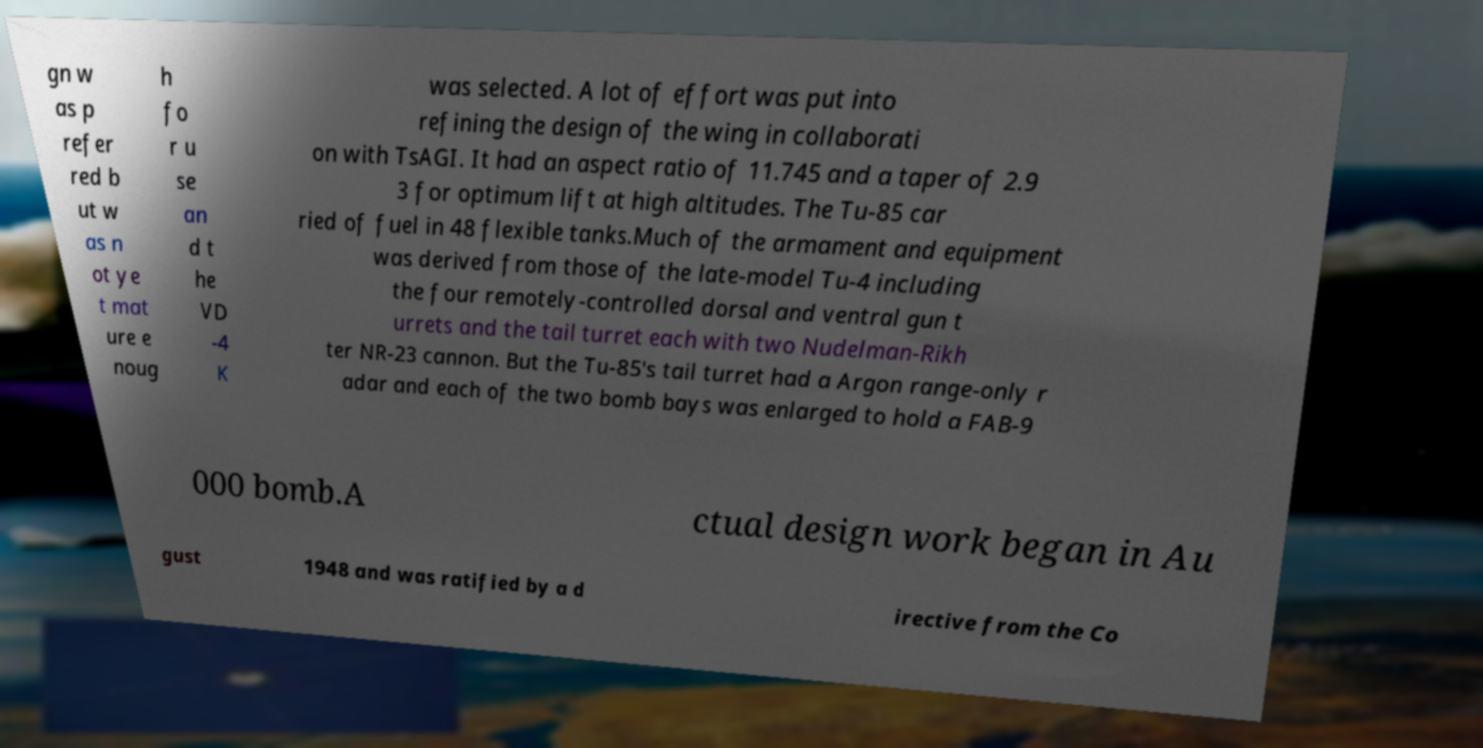For documentation purposes, I need the text within this image transcribed. Could you provide that? gn w as p refer red b ut w as n ot ye t mat ure e noug h fo r u se an d t he VD -4 K was selected. A lot of effort was put into refining the design of the wing in collaborati on with TsAGI. It had an aspect ratio of 11.745 and a taper of 2.9 3 for optimum lift at high altitudes. The Tu-85 car ried of fuel in 48 flexible tanks.Much of the armament and equipment was derived from those of the late-model Tu-4 including the four remotely-controlled dorsal and ventral gun t urrets and the tail turret each with two Nudelman-Rikh ter NR-23 cannon. But the Tu-85's tail turret had a Argon range-only r adar and each of the two bomb bays was enlarged to hold a FAB-9 000 bomb.A ctual design work began in Au gust 1948 and was ratified by a d irective from the Co 